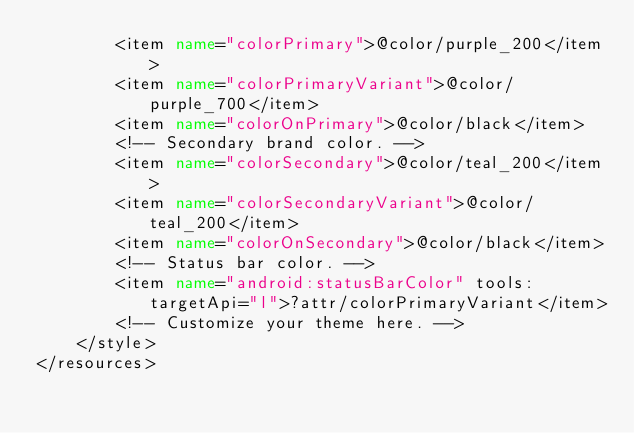Convert code to text. <code><loc_0><loc_0><loc_500><loc_500><_XML_>        <item name="colorPrimary">@color/purple_200</item>
        <item name="colorPrimaryVariant">@color/purple_700</item>
        <item name="colorOnPrimary">@color/black</item>
        <!-- Secondary brand color. -->
        <item name="colorSecondary">@color/teal_200</item>
        <item name="colorSecondaryVariant">@color/teal_200</item>
        <item name="colorOnSecondary">@color/black</item>
        <!-- Status bar color. -->
        <item name="android:statusBarColor" tools:targetApi="l">?attr/colorPrimaryVariant</item>
        <!-- Customize your theme here. -->
    </style>
</resources></code> 